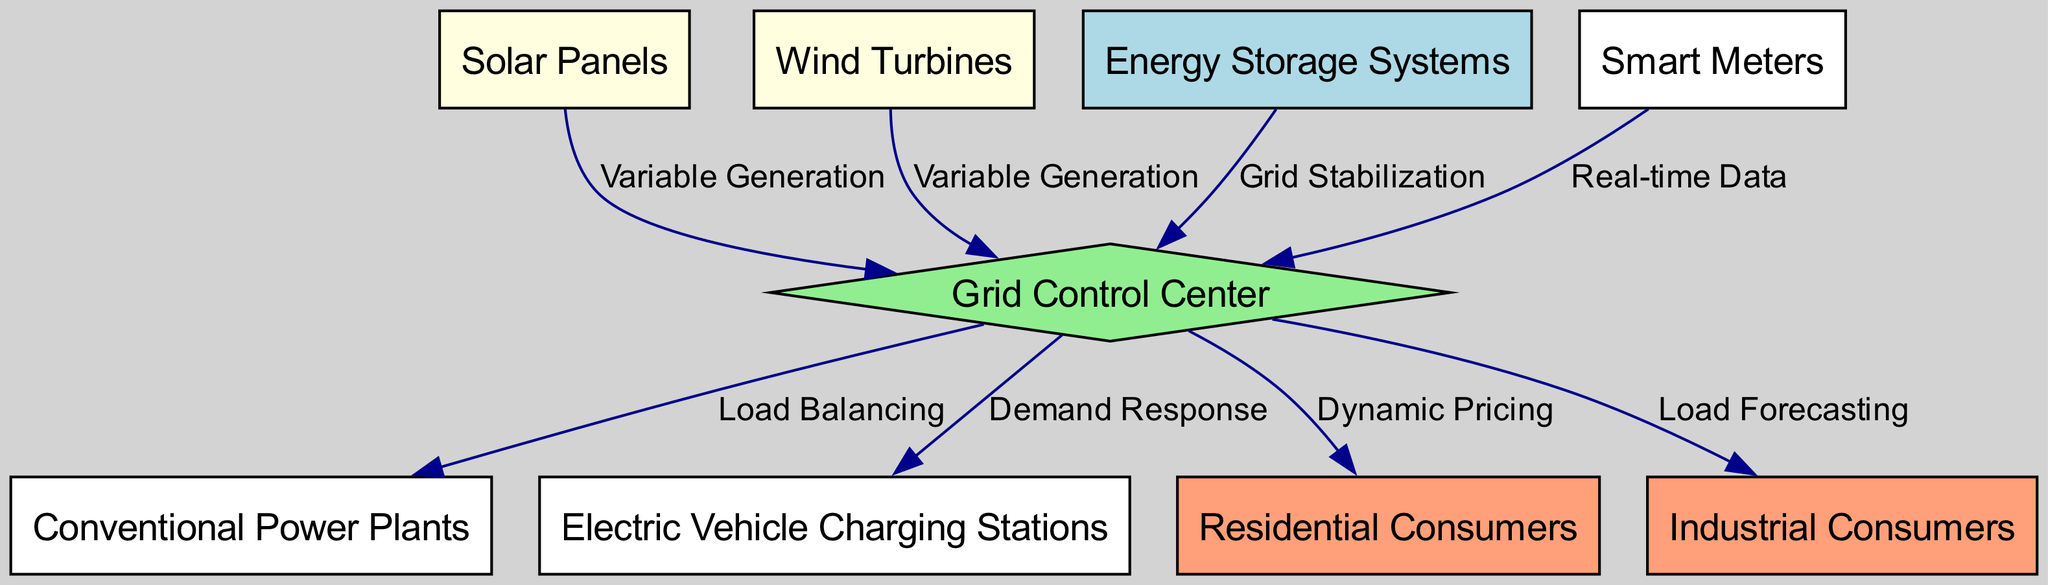What are the sources of variable generation in the diagram? The diagram shows two nodes labeled "Solar Panels" and "Wind Turbines" as sources of variable generation. These nodes point to the "Grid Control Center."
Answer: Solar Panels, Wind Turbines What type of information do the smart meters relay to the grid control center? The edge connecting "Smart Meters" and "Grid Control Center" is labeled "Real-time Data," indicating that the smart meters provide real-time information about energy usage to the control center.
Answer: Real-time Data How many total nodes are present in the diagram? By counting the distinct nodes listed in the data, there are nine nodes in total, including all consumer types, generators, and control elements.
Answer: 9 What role does the Energy Storage System play in the smart grid? The edge from "Energy Storage Systems" to "Grid Control Center" is labeled "Grid Stabilization," meaning that the Energy Storage System helps to stabilize the grid by managing energy supplies.
Answer: Grid Stabilization Which consumer type is associated with dynamic pricing? The edge from "Grid Control Center" to "Residential Consumers" specifies "Dynamic Pricing." This relationship indicates that pricing varies for residential consumers based on current grid conditions.
Answer: Residential Consumers Which component is responsible for load balancing in the diagram? The edge from "Grid Control Center" to "Conventional Power Plants" is labeled "Load Balancing," indicating that the control center manages load distribution among power plants to maintain supply-demand balance.
Answer: Conventional Power Plants What interaction occurs between the grid control center and electric vehicle charging stations? The edge between "Grid Control Center" and "Electric Vehicle Charging Stations" is labeled "Demand Response," which implies that the grid control center can adjust charging in response to grid conditions or demand.
Answer: Demand Response What is the relationship between industrial consumers and load forecasting in the diagram? The edge from "Grid Control Center" to "Industrial Consumers" is labeled "Load Forecasting," showing that the control center uses forecasting to predict the energy needs of industrial consumers.
Answer: Load Forecasting How many edges connect to the grid control center? By analyzing the edges emanating from "Grid Control Center," there are five distinct edges connected to it, indicating interactions with various components in the system.
Answer: 5 